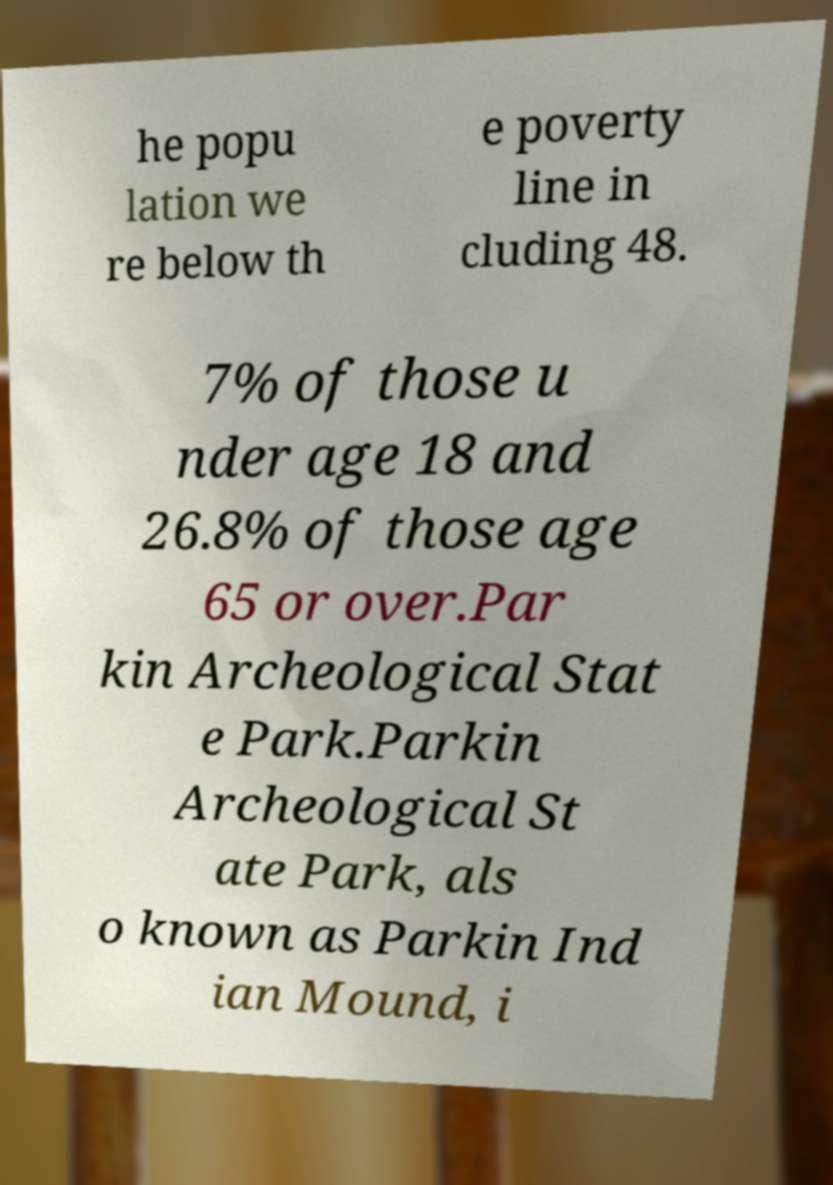Can you accurately transcribe the text from the provided image for me? he popu lation we re below th e poverty line in cluding 48. 7% of those u nder age 18 and 26.8% of those age 65 or over.Par kin Archeological Stat e Park.Parkin Archeological St ate Park, als o known as Parkin Ind ian Mound, i 